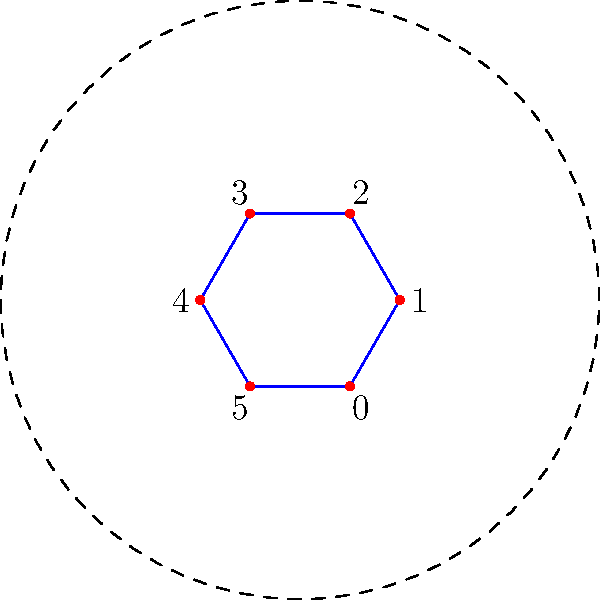In the cyclic group of order 6 represented as a hexagon, what is the result of the group operation $4 \circ 3$? Express your answer as a single integer mod 6. To solve this problem, we need to follow these steps:

1. Understand the representation: In this cyclic group of order 6, the elements are labeled 0 to 5 around the hexagon.

2. Interpret the group operation: The operation $\circ$ in this context is addition modulo 6. This means we add the numbers and take the result modulo 6.

3. Perform the calculation:
   $4 \circ 3 = 4 + 3 = 7$

4. Apply modulo 6:
   $7 \equiv 1 \pmod{6}$

   This is because 7 divided by 6 gives a remainder of 1.

5. Verify on the hexagon: Starting at vertex 4 and moving 3 steps clockwise brings us to vertex 1.

Therefore, in this cyclic group, $4 \circ 3 = 1$.
Answer: $1$ 